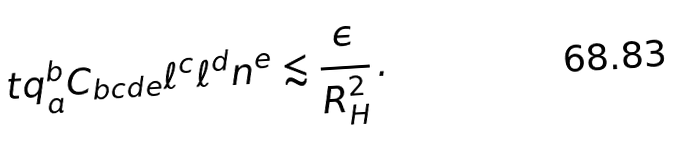<formula> <loc_0><loc_0><loc_500><loc_500>\ t q _ { a } ^ { b } C _ { b c d e } \ell ^ { c } \ell ^ { d } n ^ { e } \lesssim \frac { \epsilon } { R _ { H } ^ { 2 } } \, .</formula> 